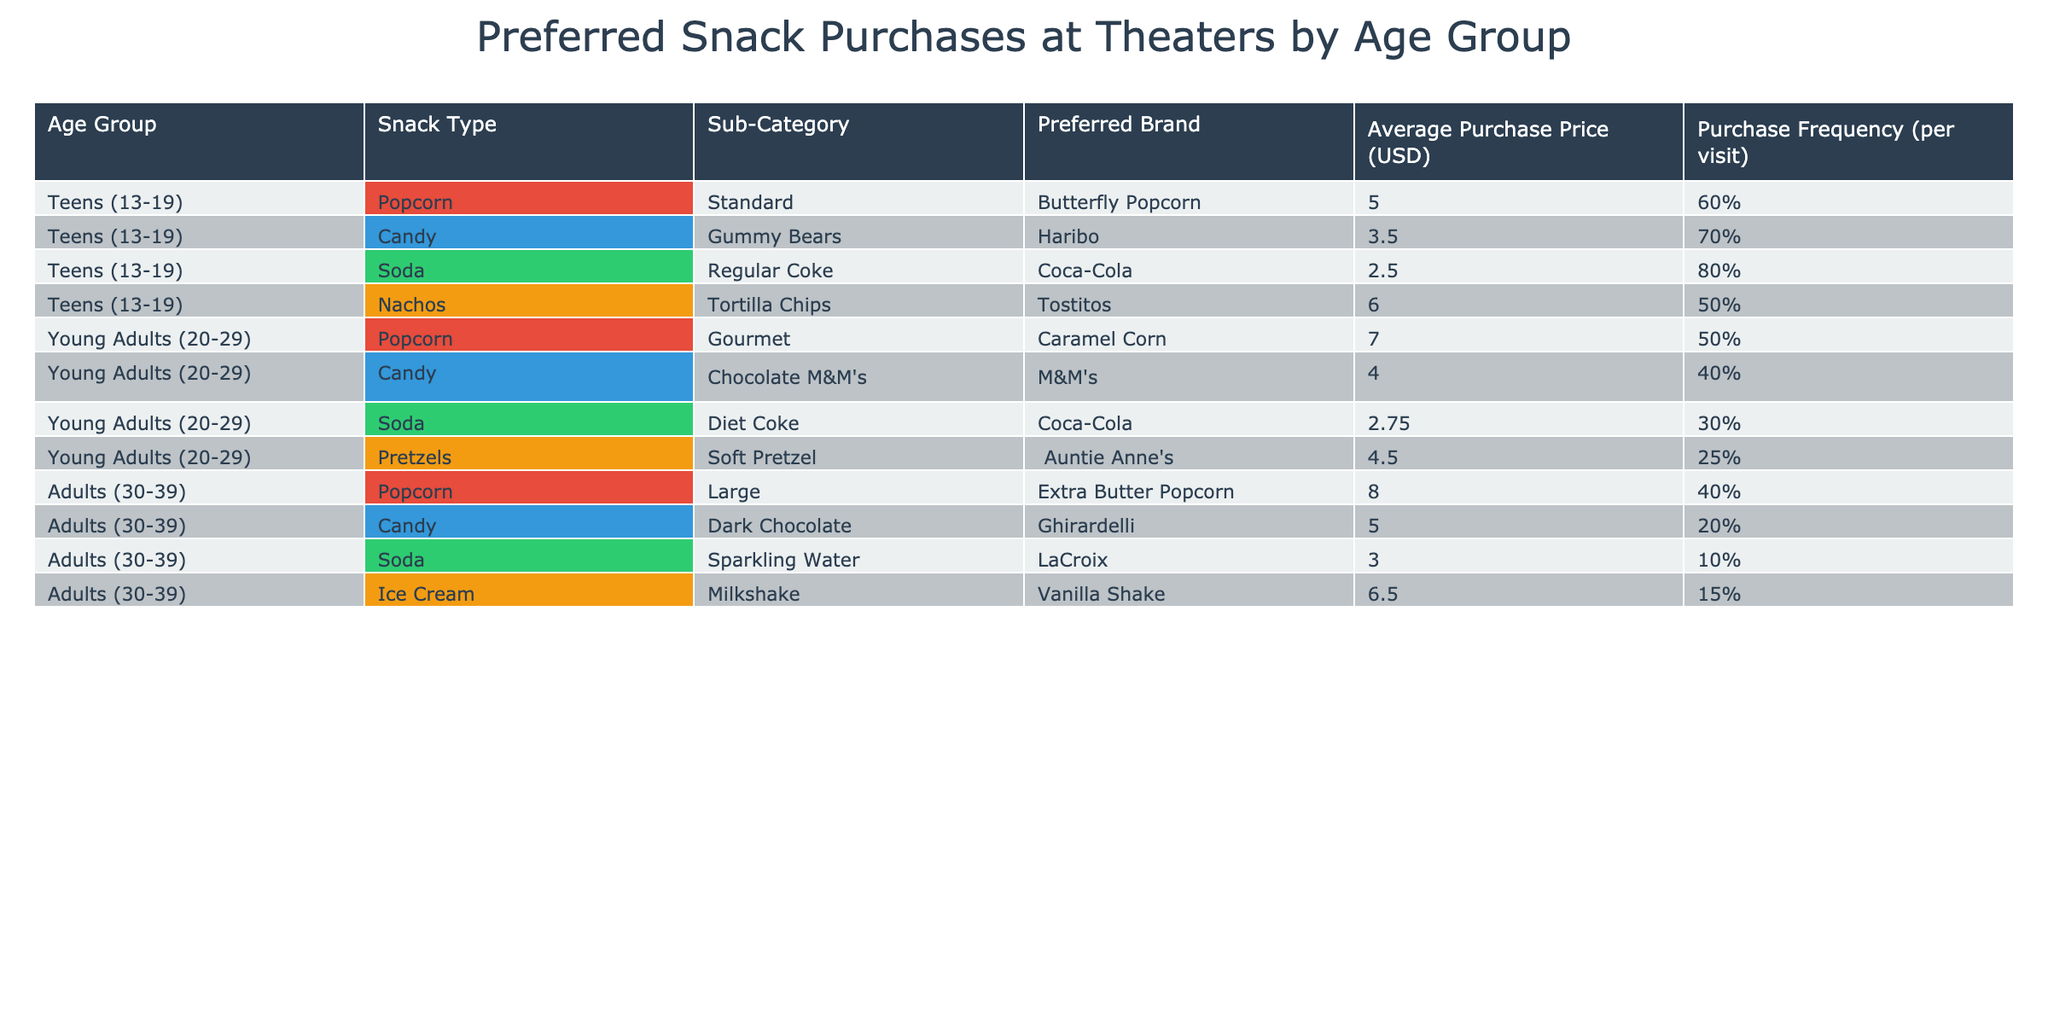What is the preferred brand of candy for teens? According to the table, for the age group of teens (13-19), the preferred candy brand is Gummy Bears by Haribo.
Answer: Haribo Which age group buys nachos most frequently? The table shows that teens (13-19) have a purchase frequency of 50% for nachos, which is higher than the other age groups that do not have nachos listed. Therefore, teens are the ones who buy nachos most frequently.
Answer: Teens (13-19) What is the average purchase price of soda among young adults? For young adults (20-29), the average purchase price of soda is 2.75 USD. There’s only one soda listed for this age group, hence no need for averaging.
Answer: 2.75 USD Is the preferred snack for adults more expensive than for teens? The average purchase price for snacks among adults can be calculated: Popcorn - 8.00, Candy - 5.00, Soda - 3.00, Ice Cream - 6.50. The average is (8.00 + 5.00 + 3.00 + 6.50) / 4 = 5.625 USD. For teens, the snacks are Popcorn - 5.00, Candy - 3.50, Soda - 2.50, Nachos - 6.00 giving an average of (5.00 + 3.50 + 2.50 + 6.00) / 4 = 4.00 USD. Since 5.625 > 4.00, then yes, adults spend more on their preferred snacks.
Answer: Yes What is the total purchase frequency for candy among all age groups? By looking at the table, teens (70%) + young adults (40%) + adults (20%) = 130%. Therefore, the total purchase frequency for candy among all age groups is 130%.
Answer: 130% 